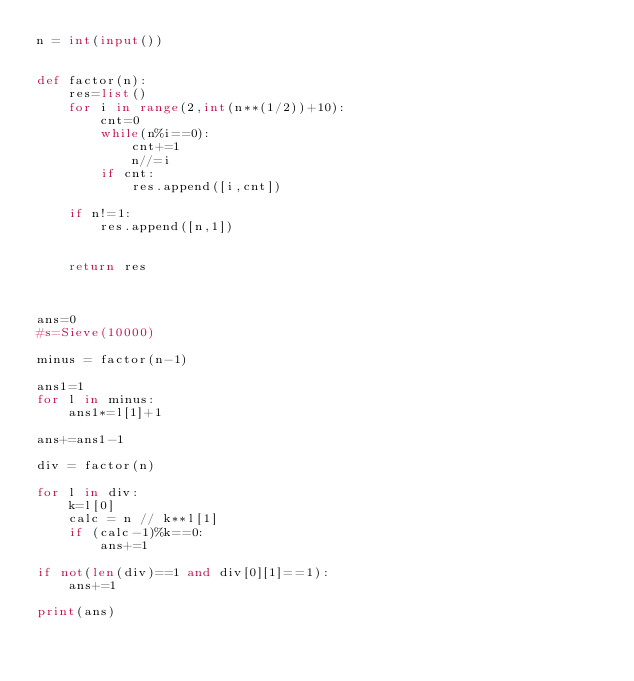<code> <loc_0><loc_0><loc_500><loc_500><_Python_>n = int(input())


def factor(n):
    res=list()
    for i in range(2,int(n**(1/2))+10):
        cnt=0
        while(n%i==0):
            cnt+=1
            n//=i
        if cnt:
            res.append([i,cnt])

    if n!=1:
        res.append([n,1])


    return res

    

ans=0
#s=Sieve(10000)

minus = factor(n-1)

ans1=1
for l in minus:
    ans1*=l[1]+1

ans+=ans1-1

div = factor(n)

for l in div:
    k=l[0]
    calc = n // k**l[1]
    if (calc-1)%k==0:
        ans+=1

if not(len(div)==1 and div[0][1]==1):
    ans+=1

print(ans)
</code> 